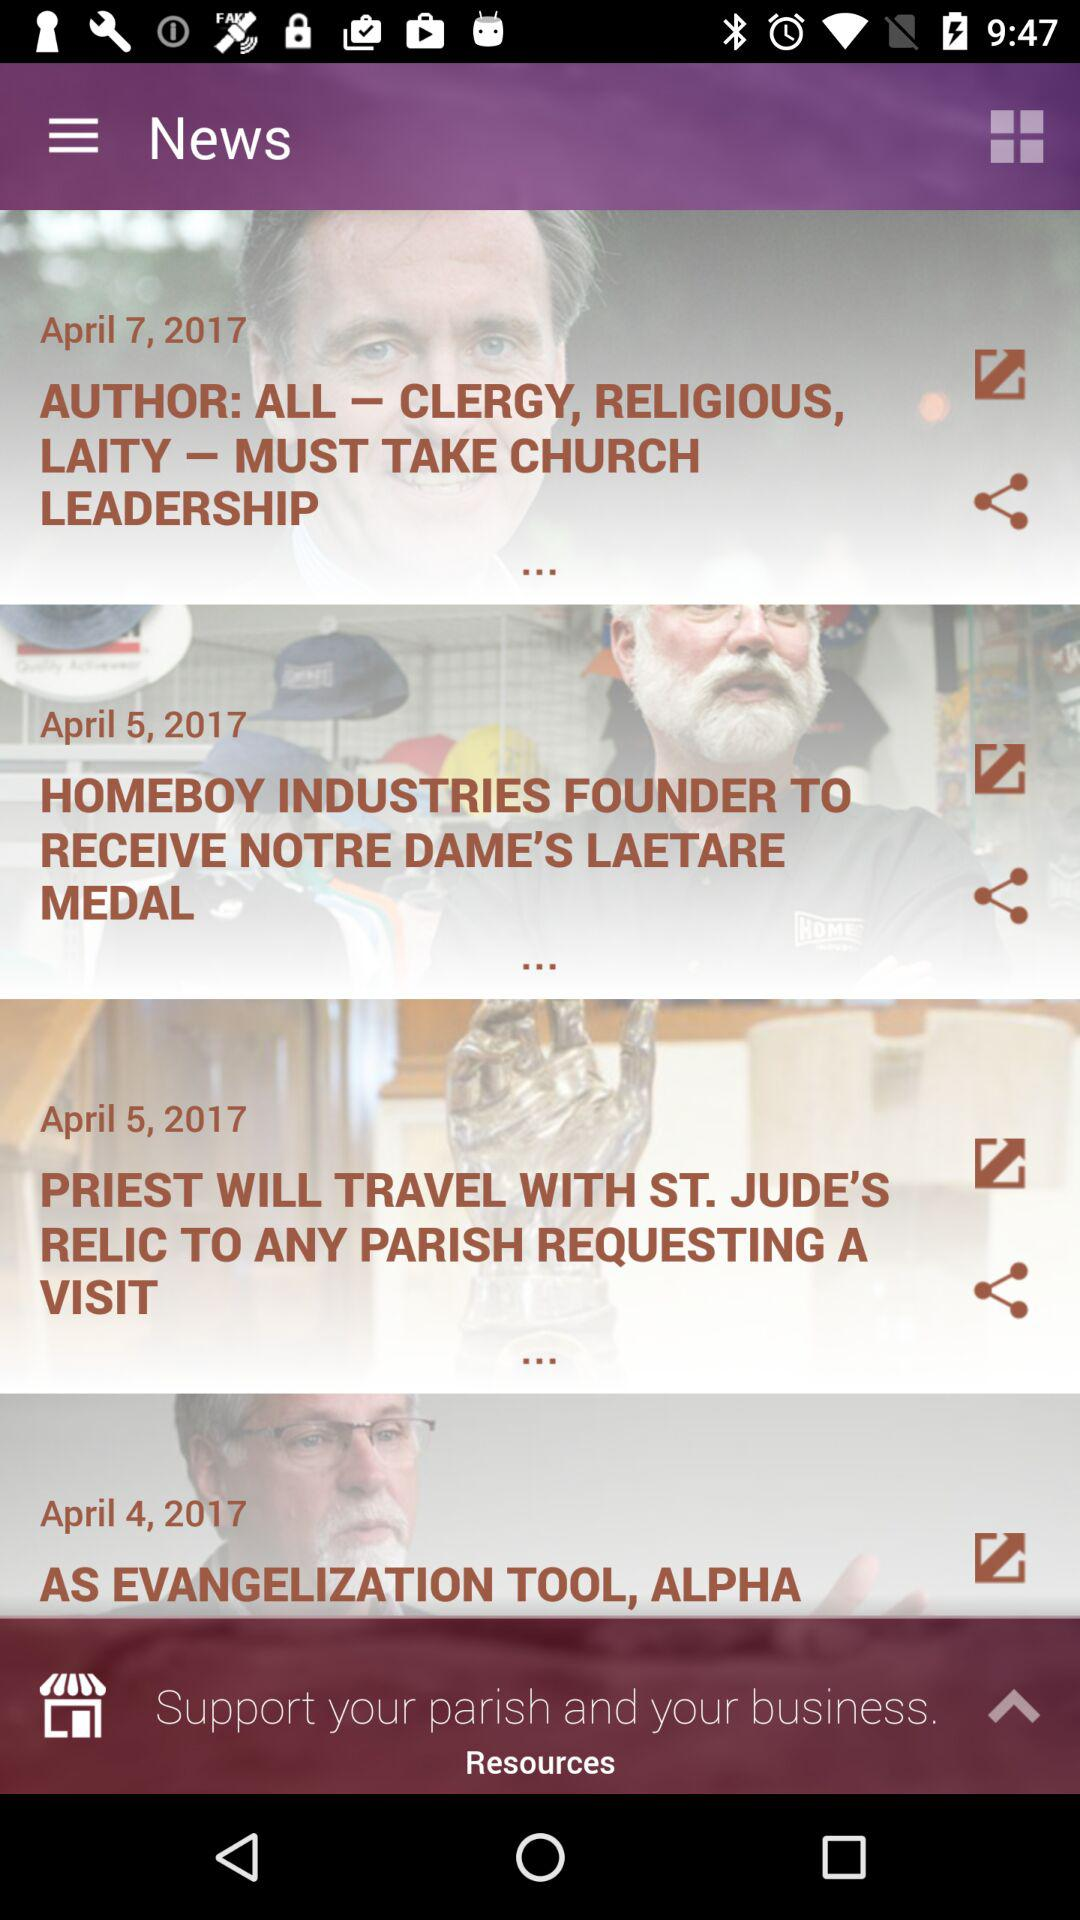On which date was the news "AUTHOR: ALL – CLERGY, RELIGIOUS" posted? The news "AUTHOR: ALL – CLERGY, RELIGIOUS" was posted on April 7, 2017. 